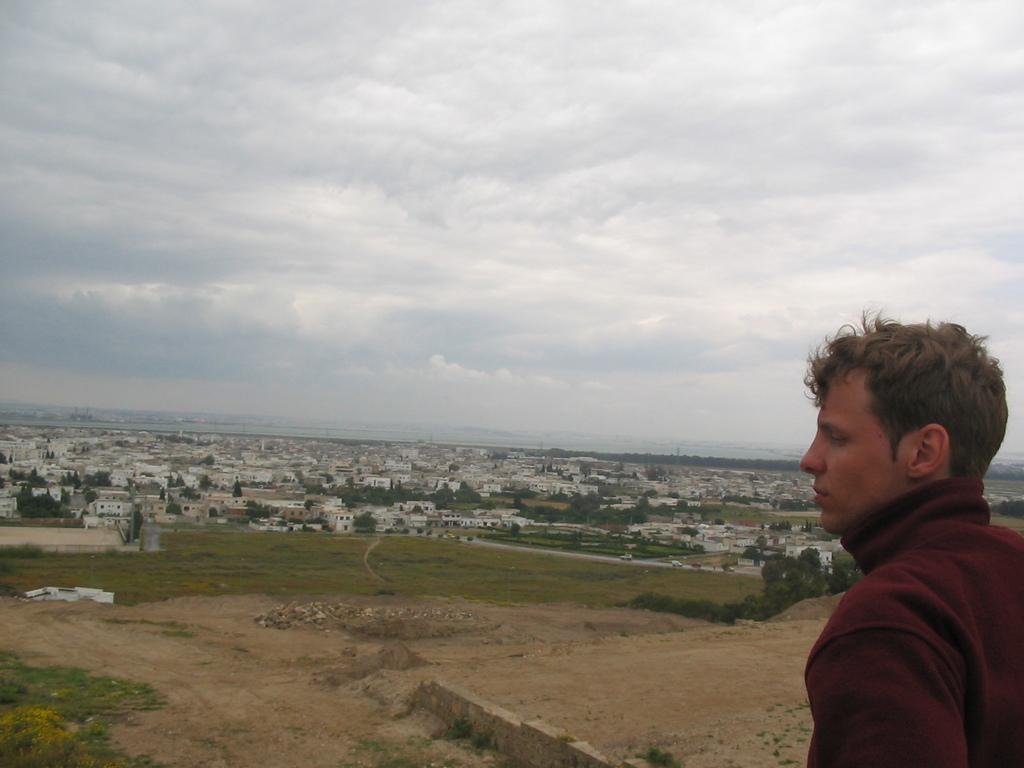How would you summarize this image in a sentence or two? On the right side of the image, we can see a person. Background there are so many houses, buildings, trees, grass we can see. Top of the image, there is a cloudy sky. 